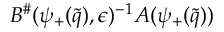Convert formula to latex. <formula><loc_0><loc_0><loc_500><loc_500>B ^ { \# } ( \psi _ { + } ( \tilde { q } ) , \epsilon ) ^ { - 1 } A ( \psi _ { + } ( \tilde { q } ) )</formula> 